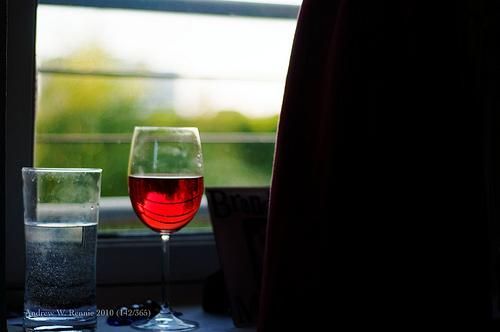Question: how many people are visible in the photo?
Choices:
A. Six.
B. Twenty-two.
C. None.
D. One.
Answer with the letter. Answer: C Question: what color is the large object on the right side of the photo?
Choices:
A. Orange.
B. Green.
C. Blue.
D. Black.
Answer with the letter. Answer: D Question: what is in the background of the photo beyond the window?
Choices:
A. Clouds.
B. A lake.
C. Trees.
D. Houses.
Answer with the letter. Answer: C Question: what color is the liquid in the drinking glass on the far left of the photo?
Choices:
A. Burghundy.
B. Orange.
C. Light brown.
D. Clear.
Answer with the letter. Answer: D Question: where is this scene taking place?
Choices:
A. At a desk.
B. At a window.
C. At a table.
D. At a door.
Answer with the letter. Answer: B 